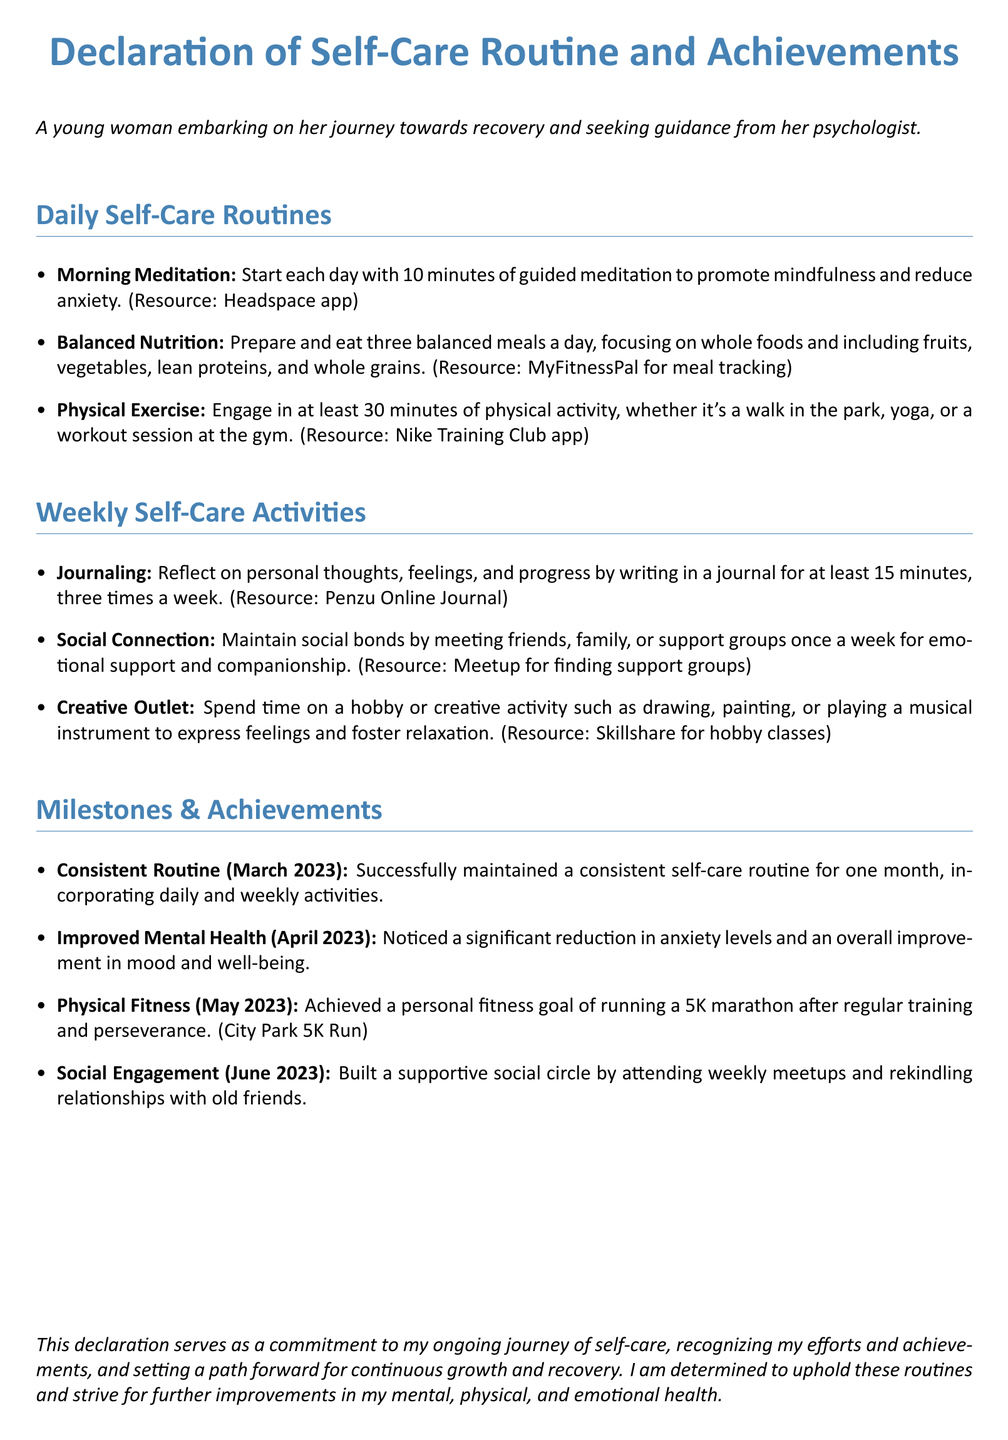What is the title of the document? The title is stated at the beginning of the document and highlights the focus of the content.
Answer: Declaration of Self-Care Routine and Achievements How long is the morning meditation duration? The document specifies the duration of the morning meditation routine under daily self-care routines.
Answer: 10 minutes What is the main focus of balanced nutrition? The focus of balanced nutrition is outlined in terms of the types of food recommended.
Answer: Whole foods How frequently should journaling be done? The document indicates the frequency of journaling within the weekly self-care activities section.
Answer: Three times a week What milestone was achieved in April 2023? The document describes milestones achieved in specific months, specifically noting improvements.
Answer: Improved Mental Health What type of exercise is recommended daily? The document suggests a specific category of activity that constitutes physical exercise.
Answer: Physical activity Which app is recommended for meal tracking? One of the resources listed for supporting balanced nutrition is associated with a specific app.
Answer: MyFitnessPal What social activity is suggested once a week? The document outlines social activities in the weekly section that promote connection.
Answer: Meeting friends What was achieved by May 2023? The milestones mentioned in the document specifically highlight achievements related to fitness.
Answer: Physical Fitness 